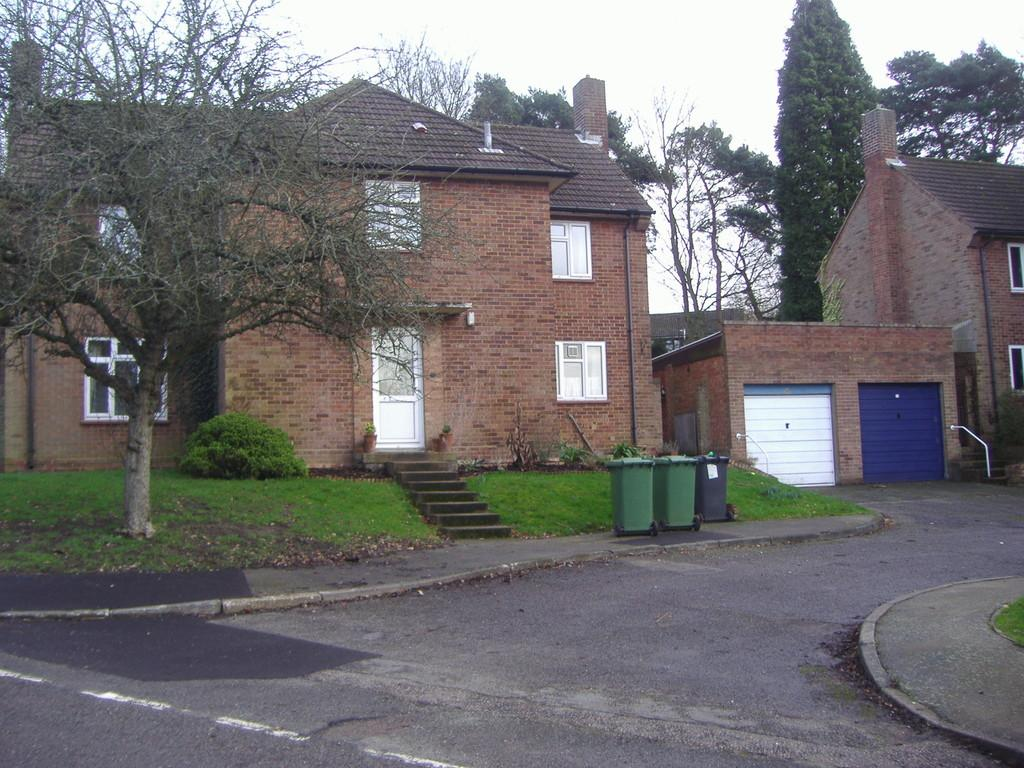What type of structures are visible in the image? There are houses with windows in the image. What objects are in front of the houses? There are bins and grass in front of the houses. What type of vegetation is present in front of the houses? There is a tree and plants in front of the houses. What can be seen in the background of the image? There are trees in the background of the image. What type of joke is being told by the porter in the image? There is no porter or joke present in the image. What advice does the father give to his children in the image? There is no father or children present in the image. 